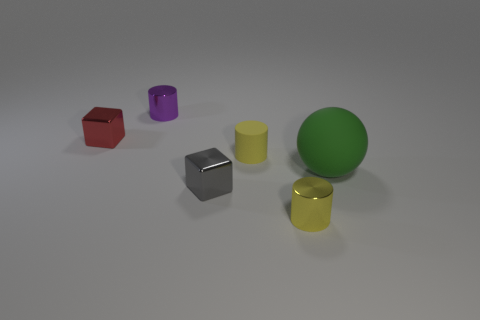What is the color of the tiny metallic cylinder left of the small shiny object right of the small gray shiny object?
Give a very brief answer. Purple. Is the red thing made of the same material as the yellow thing in front of the rubber cylinder?
Offer a terse response. Yes. The small shiny block that is in front of the metallic thing that is to the left of the small metallic cylinder behind the red metallic thing is what color?
Provide a short and direct response. Gray. Is there anything else that is the same shape as the small yellow shiny object?
Your answer should be very brief. Yes. Is the number of small gray objects greater than the number of yellow objects?
Your response must be concise. No. What number of small things are both on the left side of the small purple cylinder and on the right side of the matte cylinder?
Ensure brevity in your answer.  0. There is a tiny block to the right of the purple cylinder; what number of purple things are in front of it?
Offer a terse response. 0. Is the size of the shiny block that is in front of the yellow matte thing the same as the metal cube behind the green matte ball?
Ensure brevity in your answer.  Yes. How many large brown matte cylinders are there?
Your answer should be compact. 0. How many gray blocks have the same material as the purple object?
Give a very brief answer. 1. 